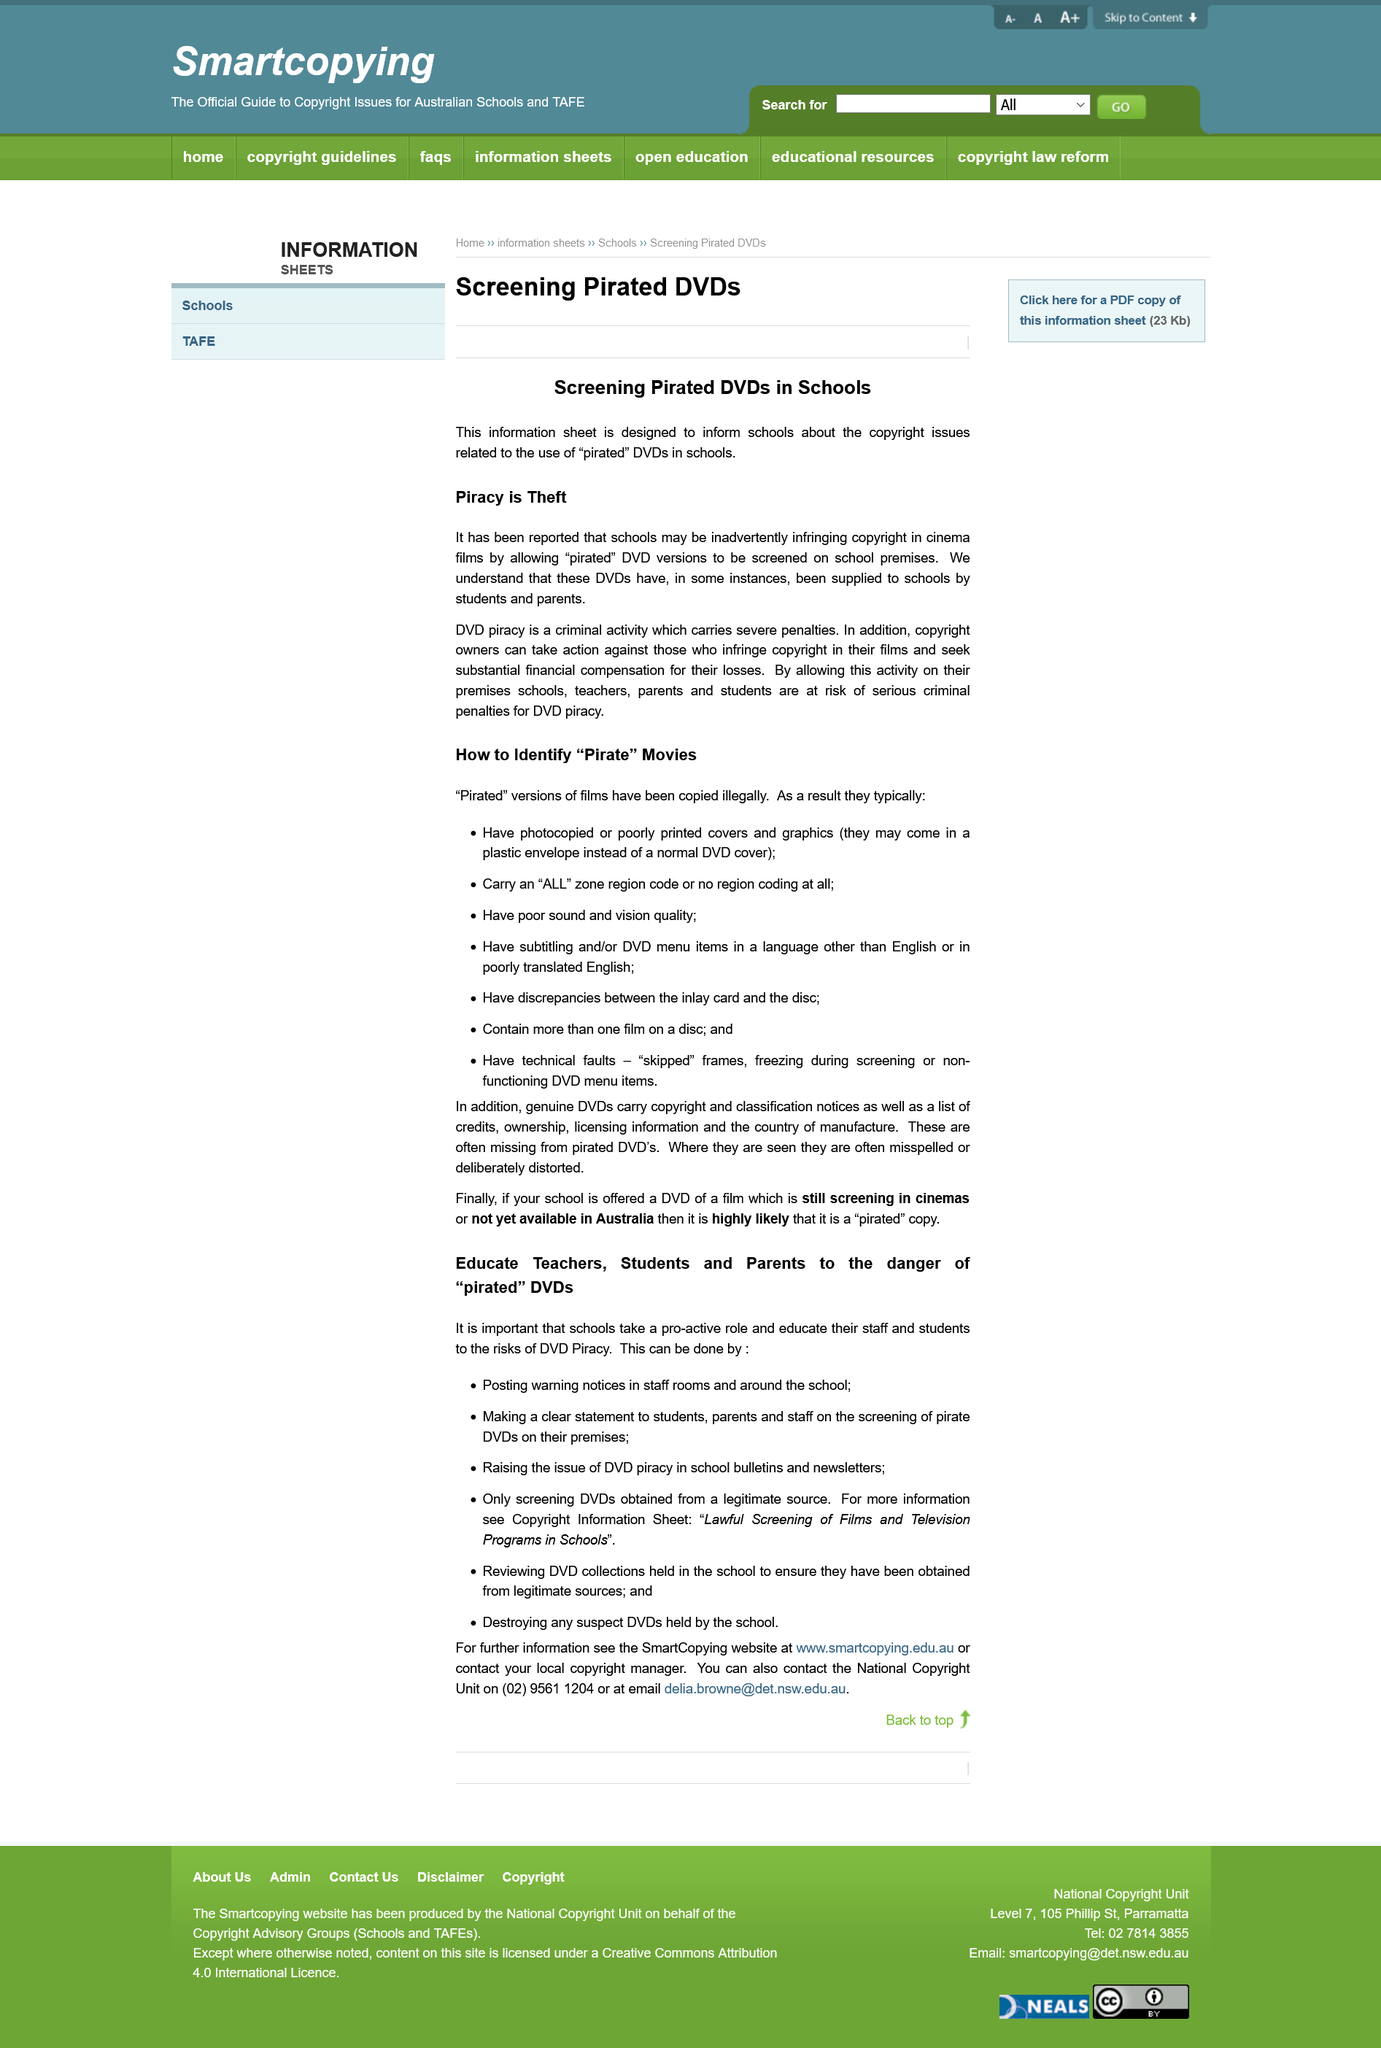Give some essential details in this illustration. I, [Name], hereby declare that if the school is offered a movie DVD that is either a copy from the cinema or has not yet arrived in Austria, it could potentially be a pirated copy. Illegally copied movies typically have poor sound and vision quality. I, as a concerned individual, call for the education of teachers, students, and parents about the dangers and consequences of using pirated DVDs, to minimize their use and promote the legal and ethical distribution of media. Pirated DVDs are able to make their way into schools through the actions of students and parents who obtain and distribute them. Pirated films are those that have been copied illegally. 